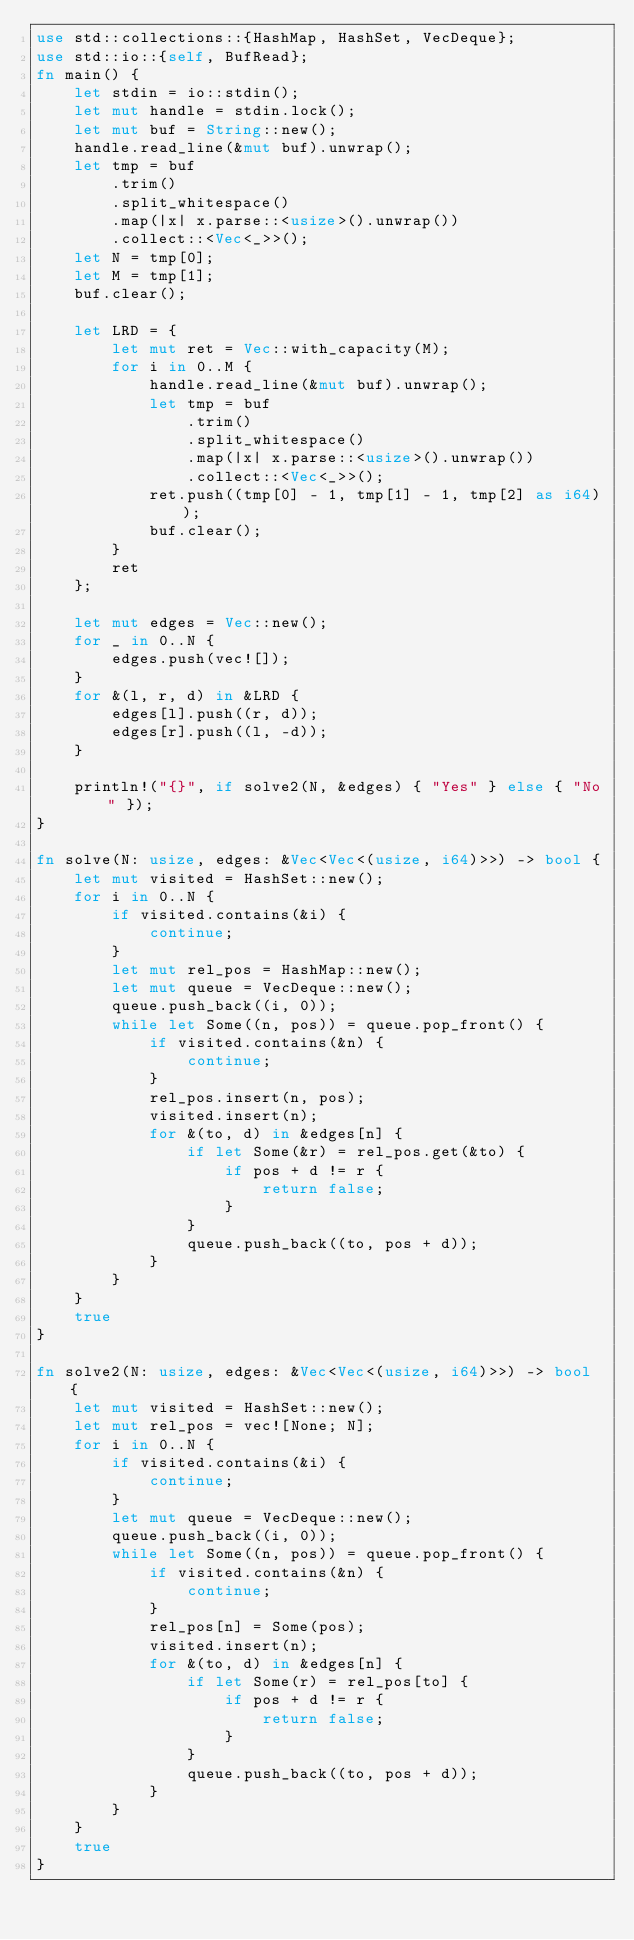<code> <loc_0><loc_0><loc_500><loc_500><_Rust_>use std::collections::{HashMap, HashSet, VecDeque};
use std::io::{self, BufRead};
fn main() {
    let stdin = io::stdin();
    let mut handle = stdin.lock();
    let mut buf = String::new();
    handle.read_line(&mut buf).unwrap();
    let tmp = buf
        .trim()
        .split_whitespace()
        .map(|x| x.parse::<usize>().unwrap())
        .collect::<Vec<_>>();
    let N = tmp[0];
    let M = tmp[1];
    buf.clear();

    let LRD = {
        let mut ret = Vec::with_capacity(M);
        for i in 0..M {
            handle.read_line(&mut buf).unwrap();
            let tmp = buf
                .trim()
                .split_whitespace()
                .map(|x| x.parse::<usize>().unwrap())
                .collect::<Vec<_>>();
            ret.push((tmp[0] - 1, tmp[1] - 1, tmp[2] as i64));
            buf.clear();
        }
        ret
    };

    let mut edges = Vec::new();
    for _ in 0..N {
        edges.push(vec![]);
    }
    for &(l, r, d) in &LRD {
        edges[l].push((r, d));
        edges[r].push((l, -d));
    }

    println!("{}", if solve2(N, &edges) { "Yes" } else { "No" });
}

fn solve(N: usize, edges: &Vec<Vec<(usize, i64)>>) -> bool {
    let mut visited = HashSet::new();
    for i in 0..N {
        if visited.contains(&i) {
            continue;
        }
        let mut rel_pos = HashMap::new();
        let mut queue = VecDeque::new();
        queue.push_back((i, 0));
        while let Some((n, pos)) = queue.pop_front() {
            if visited.contains(&n) {
                continue;
            }
            rel_pos.insert(n, pos);
            visited.insert(n);
            for &(to, d) in &edges[n] {
                if let Some(&r) = rel_pos.get(&to) {
                    if pos + d != r {
                        return false;
                    }
                }
                queue.push_back((to, pos + d));
            }
        }
    }
    true
}

fn solve2(N: usize, edges: &Vec<Vec<(usize, i64)>>) -> bool {
    let mut visited = HashSet::new();
    let mut rel_pos = vec![None; N];
    for i in 0..N {
        if visited.contains(&i) {
            continue;
        }
        let mut queue = VecDeque::new();
        queue.push_back((i, 0));
        while let Some((n, pos)) = queue.pop_front() {
            if visited.contains(&n) {
                continue;
            }
            rel_pos[n] = Some(pos);
            visited.insert(n);
            for &(to, d) in &edges[n] {
                if let Some(r) = rel_pos[to] {
                    if pos + d != r {
                        return false;
                    }
                }
                queue.push_back((to, pos + d));
            }
        }
    }
    true
}
</code> 